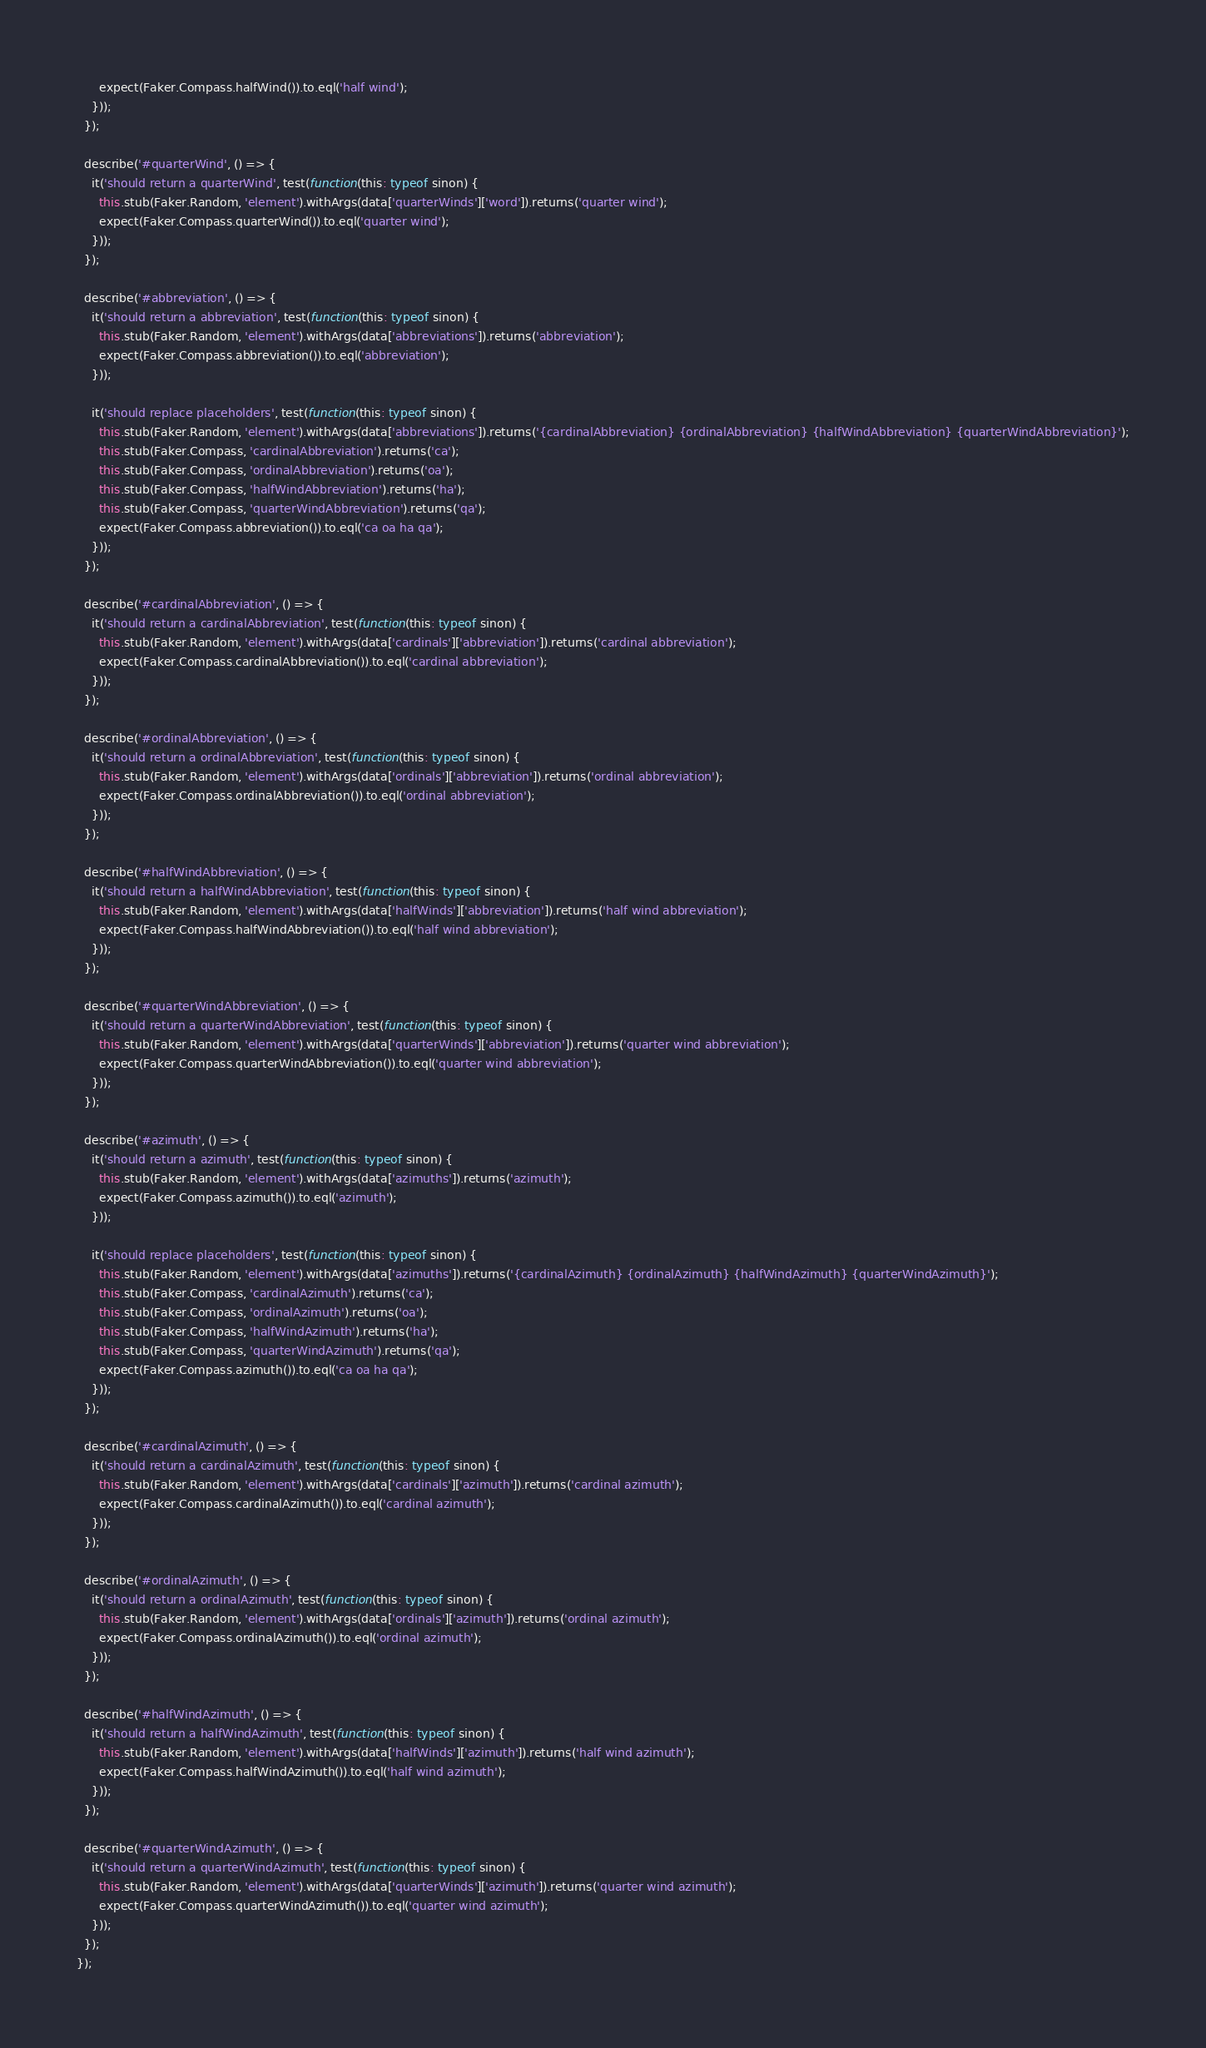<code> <loc_0><loc_0><loc_500><loc_500><_TypeScript_>      expect(Faker.Compass.halfWind()).to.eql('half wind');
    }));
  });

  describe('#quarterWind', () => {
    it('should return a quarterWind', test(function(this: typeof sinon) {
      this.stub(Faker.Random, 'element').withArgs(data['quarterWinds']['word']).returns('quarter wind');
      expect(Faker.Compass.quarterWind()).to.eql('quarter wind');
    }));
  });

  describe('#abbreviation', () => {
    it('should return a abbreviation', test(function(this: typeof sinon) {
      this.stub(Faker.Random, 'element').withArgs(data['abbreviations']).returns('abbreviation');
      expect(Faker.Compass.abbreviation()).to.eql('abbreviation');
    }));

    it('should replace placeholders', test(function(this: typeof sinon) {
      this.stub(Faker.Random, 'element').withArgs(data['abbreviations']).returns('{cardinalAbbreviation} {ordinalAbbreviation} {halfWindAbbreviation} {quarterWindAbbreviation}');
      this.stub(Faker.Compass, 'cardinalAbbreviation').returns('ca');
      this.stub(Faker.Compass, 'ordinalAbbreviation').returns('oa');
      this.stub(Faker.Compass, 'halfWindAbbreviation').returns('ha');
      this.stub(Faker.Compass, 'quarterWindAbbreviation').returns('qa');
      expect(Faker.Compass.abbreviation()).to.eql('ca oa ha qa');
    }));
  });

  describe('#cardinalAbbreviation', () => {
    it('should return a cardinalAbbreviation', test(function(this: typeof sinon) {
      this.stub(Faker.Random, 'element').withArgs(data['cardinals']['abbreviation']).returns('cardinal abbreviation');
      expect(Faker.Compass.cardinalAbbreviation()).to.eql('cardinal abbreviation');
    }));
  });

  describe('#ordinalAbbreviation', () => {
    it('should return a ordinalAbbreviation', test(function(this: typeof sinon) {
      this.stub(Faker.Random, 'element').withArgs(data['ordinals']['abbreviation']).returns('ordinal abbreviation');
      expect(Faker.Compass.ordinalAbbreviation()).to.eql('ordinal abbreviation');
    }));
  });

  describe('#halfWindAbbreviation', () => {
    it('should return a halfWindAbbreviation', test(function(this: typeof sinon) {
      this.stub(Faker.Random, 'element').withArgs(data['halfWinds']['abbreviation']).returns('half wind abbreviation');
      expect(Faker.Compass.halfWindAbbreviation()).to.eql('half wind abbreviation');
    }));
  });

  describe('#quarterWindAbbreviation', () => {
    it('should return a quarterWindAbbreviation', test(function(this: typeof sinon) {
      this.stub(Faker.Random, 'element').withArgs(data['quarterWinds']['abbreviation']).returns('quarter wind abbreviation');
      expect(Faker.Compass.quarterWindAbbreviation()).to.eql('quarter wind abbreviation');
    }));
  });

  describe('#azimuth', () => {
    it('should return a azimuth', test(function(this: typeof sinon) {
      this.stub(Faker.Random, 'element').withArgs(data['azimuths']).returns('azimuth');
      expect(Faker.Compass.azimuth()).to.eql('azimuth');
    }));

    it('should replace placeholders', test(function(this: typeof sinon) {
      this.stub(Faker.Random, 'element').withArgs(data['azimuths']).returns('{cardinalAzimuth} {ordinalAzimuth} {halfWindAzimuth} {quarterWindAzimuth}');
      this.stub(Faker.Compass, 'cardinalAzimuth').returns('ca');
      this.stub(Faker.Compass, 'ordinalAzimuth').returns('oa');
      this.stub(Faker.Compass, 'halfWindAzimuth').returns('ha');
      this.stub(Faker.Compass, 'quarterWindAzimuth').returns('qa');
      expect(Faker.Compass.azimuth()).to.eql('ca oa ha qa');
    }));
  });

  describe('#cardinalAzimuth', () => {
    it('should return a cardinalAzimuth', test(function(this: typeof sinon) {
      this.stub(Faker.Random, 'element').withArgs(data['cardinals']['azimuth']).returns('cardinal azimuth');
      expect(Faker.Compass.cardinalAzimuth()).to.eql('cardinal azimuth');
    }));
  });

  describe('#ordinalAzimuth', () => {
    it('should return a ordinalAzimuth', test(function(this: typeof sinon) {
      this.stub(Faker.Random, 'element').withArgs(data['ordinals']['azimuth']).returns('ordinal azimuth');
      expect(Faker.Compass.ordinalAzimuth()).to.eql('ordinal azimuth');
    }));
  });

  describe('#halfWindAzimuth', () => {
    it('should return a halfWindAzimuth', test(function(this: typeof sinon) {
      this.stub(Faker.Random, 'element').withArgs(data['halfWinds']['azimuth']).returns('half wind azimuth');
      expect(Faker.Compass.halfWindAzimuth()).to.eql('half wind azimuth');
    }));
  });

  describe('#quarterWindAzimuth', () => {
    it('should return a quarterWindAzimuth', test(function(this: typeof sinon) {
      this.stub(Faker.Random, 'element').withArgs(data['quarterWinds']['azimuth']).returns('quarter wind azimuth');
      expect(Faker.Compass.quarterWindAzimuth()).to.eql('quarter wind azimuth');
    }));
  });
});
</code> 